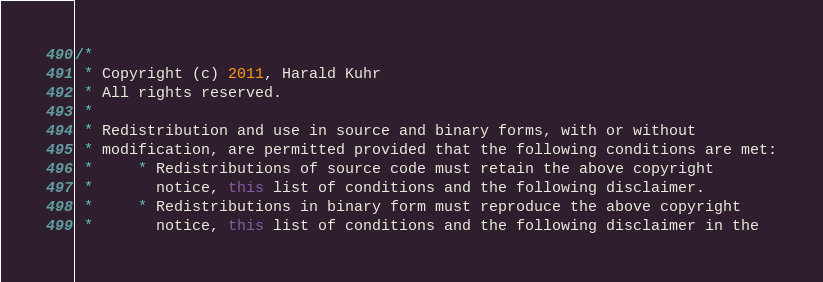Convert code to text. <code><loc_0><loc_0><loc_500><loc_500><_Java_>/*
 * Copyright (c) 2011, Harald Kuhr
 * All rights reserved.
 *
 * Redistribution and use in source and binary forms, with or without
 * modification, are permitted provided that the following conditions are met:
 *     * Redistributions of source code must retain the above copyright
 *       notice, this list of conditions and the following disclaimer.
 *     * Redistributions in binary form must reproduce the above copyright
 *       notice, this list of conditions and the following disclaimer in the</code> 